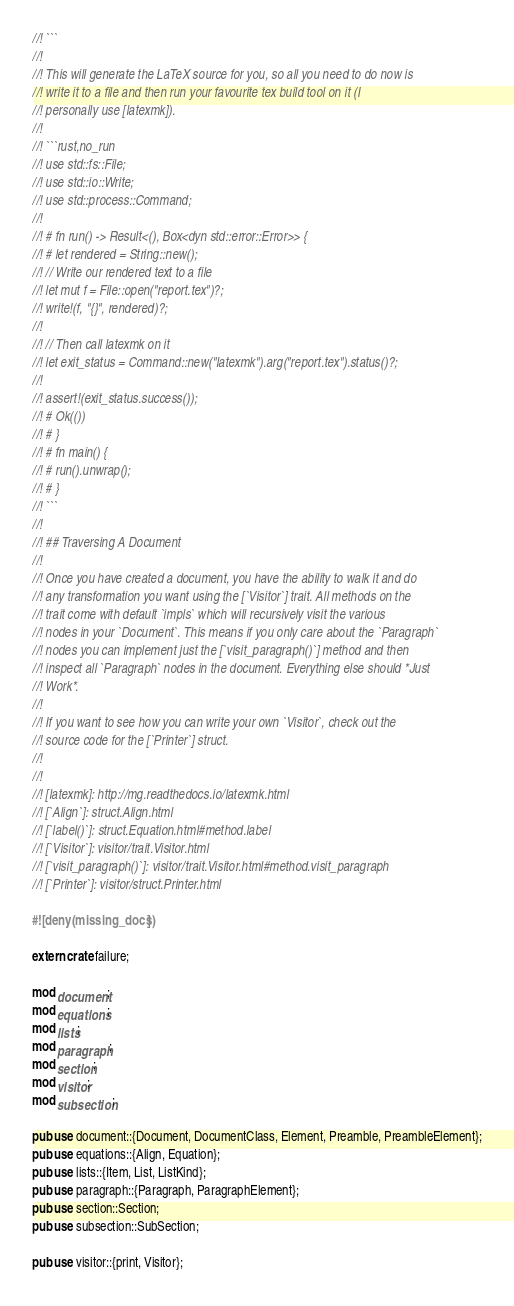<code> <loc_0><loc_0><loc_500><loc_500><_Rust_>//! ```
//!
//! This will generate the LaTeX source for you, so all you need to do now is
//! write it to a file and then run your favourite tex build tool on it (I
//! personally use [latexmk]).
//!
//! ```rust,no_run
//! use std::fs::File;
//! use std::io::Write;
//! use std::process::Command;
//!
//! # fn run() -> Result<(), Box<dyn std::error::Error>> {
//! # let rendered = String::new();
//! // Write our rendered text to a file
//! let mut f = File::open("report.tex")?;
//! write!(f, "{}", rendered)?;
//!
//! // Then call latexmk on it
//! let exit_status = Command::new("latexmk").arg("report.tex").status()?;
//!
//! assert!(exit_status.success());
//! # Ok(())
//! # }
//! # fn main() {
//! # run().unwrap();
//! # }
//! ```
//!
//! ## Traversing A Document
//!
//! Once you have created a document, you have the ability to walk it and do
//! any transformation you want using the [`Visitor`] trait. All methods on the
//! trait come with default `impls` which will recursively visit the various
//! nodes in your `Document`. This means if you only care about the `Paragraph`
//! nodes you can implement just the [`visit_paragraph()`] method and then
//! inspect all `Paragraph` nodes in the document. Everything else should *Just
//! Work*.
//!
//! If you want to see how you can write your own `Visitor`, check out the
//! source code for the [`Printer`] struct.
//!
//!
//! [latexmk]: http://mg.readthedocs.io/latexmk.html
//! [`Align`]: struct.Align.html
//! [`label()`]: struct.Equation.html#method.label
//! [`Visitor`]: visitor/trait.Visitor.html
//! [`visit_paragraph()`]: visitor/trait.Visitor.html#method.visit_paragraph
//! [`Printer`]: visitor/struct.Printer.html

#![deny(missing_docs)]

extern crate failure;

mod document;
mod equations;
mod lists;
mod paragraph;
mod section;
mod visitor;
mod subsection;

pub use document::{Document, DocumentClass, Element, Preamble, PreambleElement};
pub use equations::{Align, Equation};
pub use lists::{Item, List, ListKind};
pub use paragraph::{Paragraph, ParagraphElement};
pub use section::Section;
pub use subsection::SubSection;

pub use visitor::{print, Visitor};
</code> 